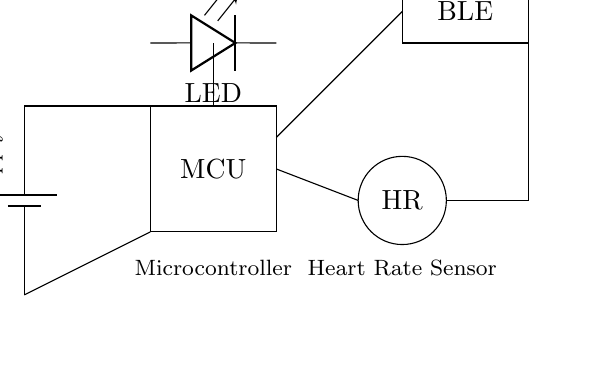What is the voltage supply in this circuit? The voltage supply is identified at the battery labeled with a value of 3.3 volts. This value represents the potential difference supplied to the circuit components.
Answer: 3.3 volts What component is used to measure heart rate? The heart rate sensor is represented by a circle labeled "HR" in the diagram. This component is specifically used for detecting pulse and measuring the heart rate.
Answer: HR What role does the microcontroller play in this circuit? The microcontroller, identified by the rectangle labeled "MCU," processes the signals from the heart rate sensor and controls the output (like the LED and Bluetooth module) in response to the measured heart rate.
Answer: Processing How is the heart rate sensor connected to the microcontroller? The heart rate sensor is connected via a direct line to the microcontroller, indicating a signal connection. This line indicates that the sensor outputs data directly to the MCU for processing.
Answer: Directly Which component transmits data wirelessly? The Bluetooth module, labeled "BLE," is used for wireless data communication, allowing the heart rate information to be transmitted to other devices, such as smartphones or computers.
Answer: Bluetooth module Where does the LED receive power from? The LED receives power from the microcontroller, which is connected to the power supply via the MCU, allowing it to turn on and indicate the status of the device.
Answer: Microcontroller What type of device is this circuit intended for? The circuit is designed for a wearable device specifically for tracking heart rate during training, which is essential for athletes to monitor their performance.
Answer: Wearable device 